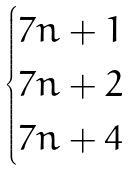Convert formula to latex. <formula><loc_0><loc_0><loc_500><loc_500>\begin{cases} 7 n + 1 \\ 7 n + 2 \\ 7 n + 4 \end{cases}</formula> 